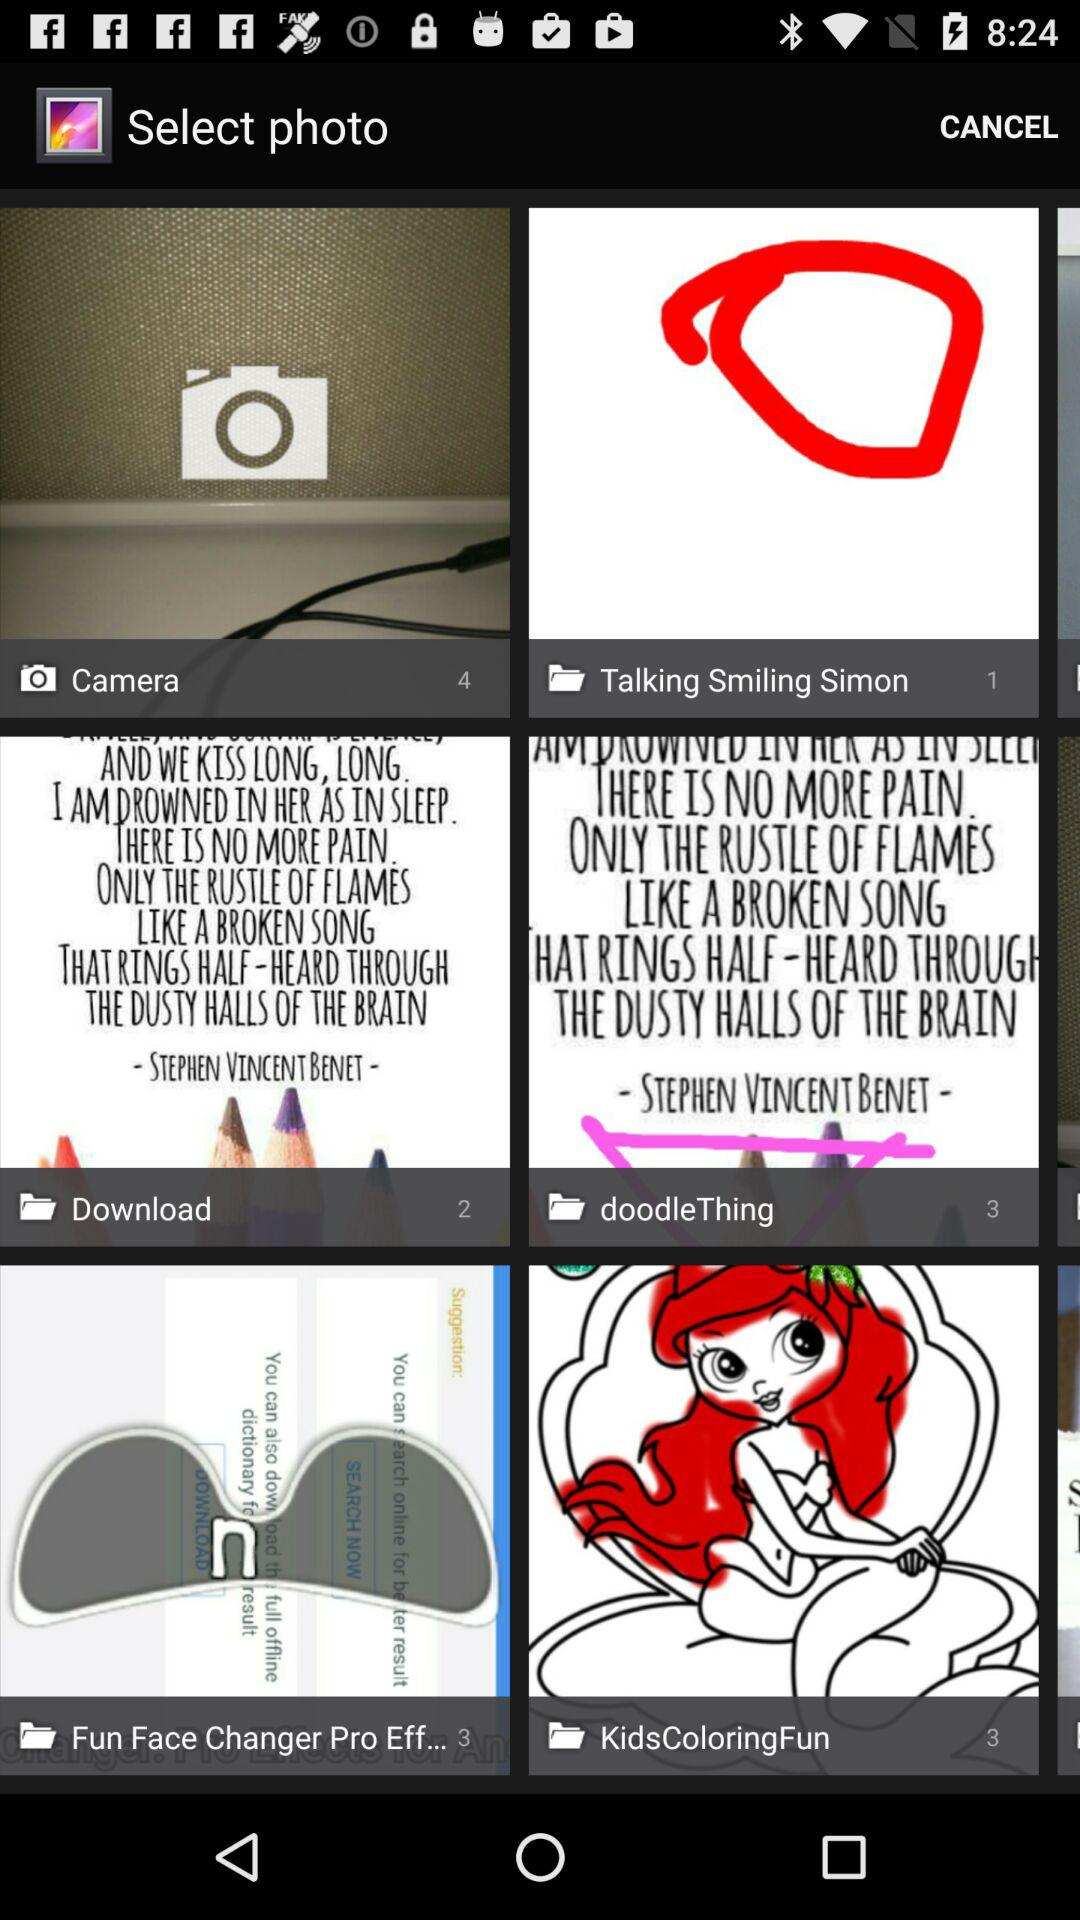How many pictures are in the camera folder? There are 4 pictures in the camera folder. 